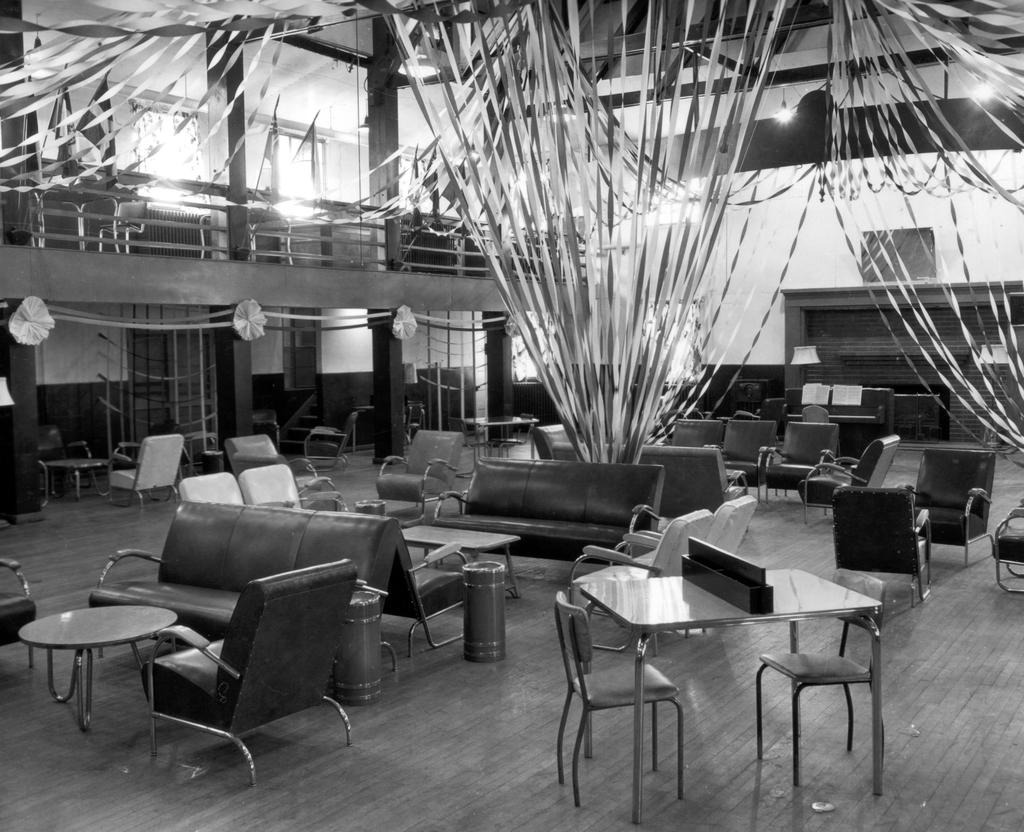What is the color scheme of the image? The image is black and white. What type of space is depicted in the image? There is a room in the image. What type of furniture can be seen in the room? There are couches, chairs, and tables in the room. What is located on the floor in the room? There is a bin on the floor. What decorative items are present in the image? There are ribbons in the image. What provides illumination in the room? There is a light in the room. Where is the light attached in the room? The light is attached to the roof. What type of sand can be seen on the floor in the image? There is no sand present in the image; it is a room with a floor covered by a different material, such as carpet or hardwood. 